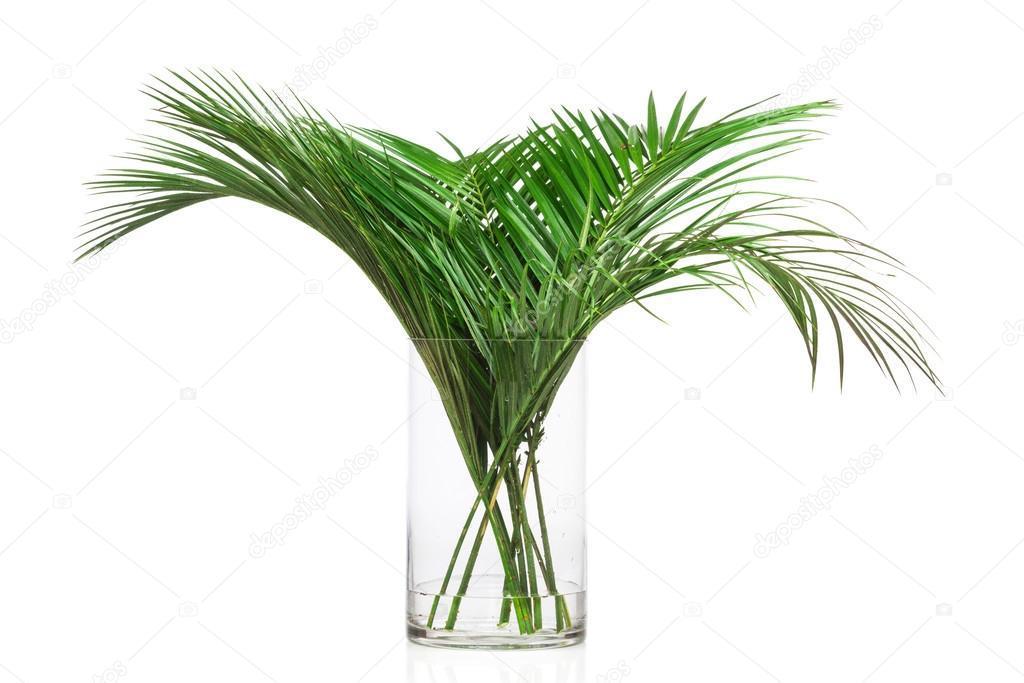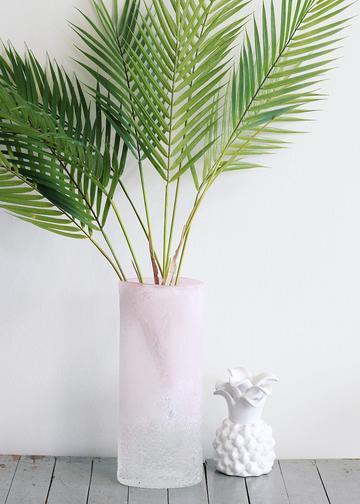The first image is the image on the left, the second image is the image on the right. Assess this claim about the two images: "In one image, a clear glass vase contains three stems of shiny, wide, dark green leaves that are arranged with each leaning in a different direction.". Correct or not? Answer yes or no. No. The first image is the image on the left, the second image is the image on the right. Given the left and right images, does the statement "The right image includes a vase holding green fronds that don't have spiky grass-like leaves." hold true? Answer yes or no. No. 